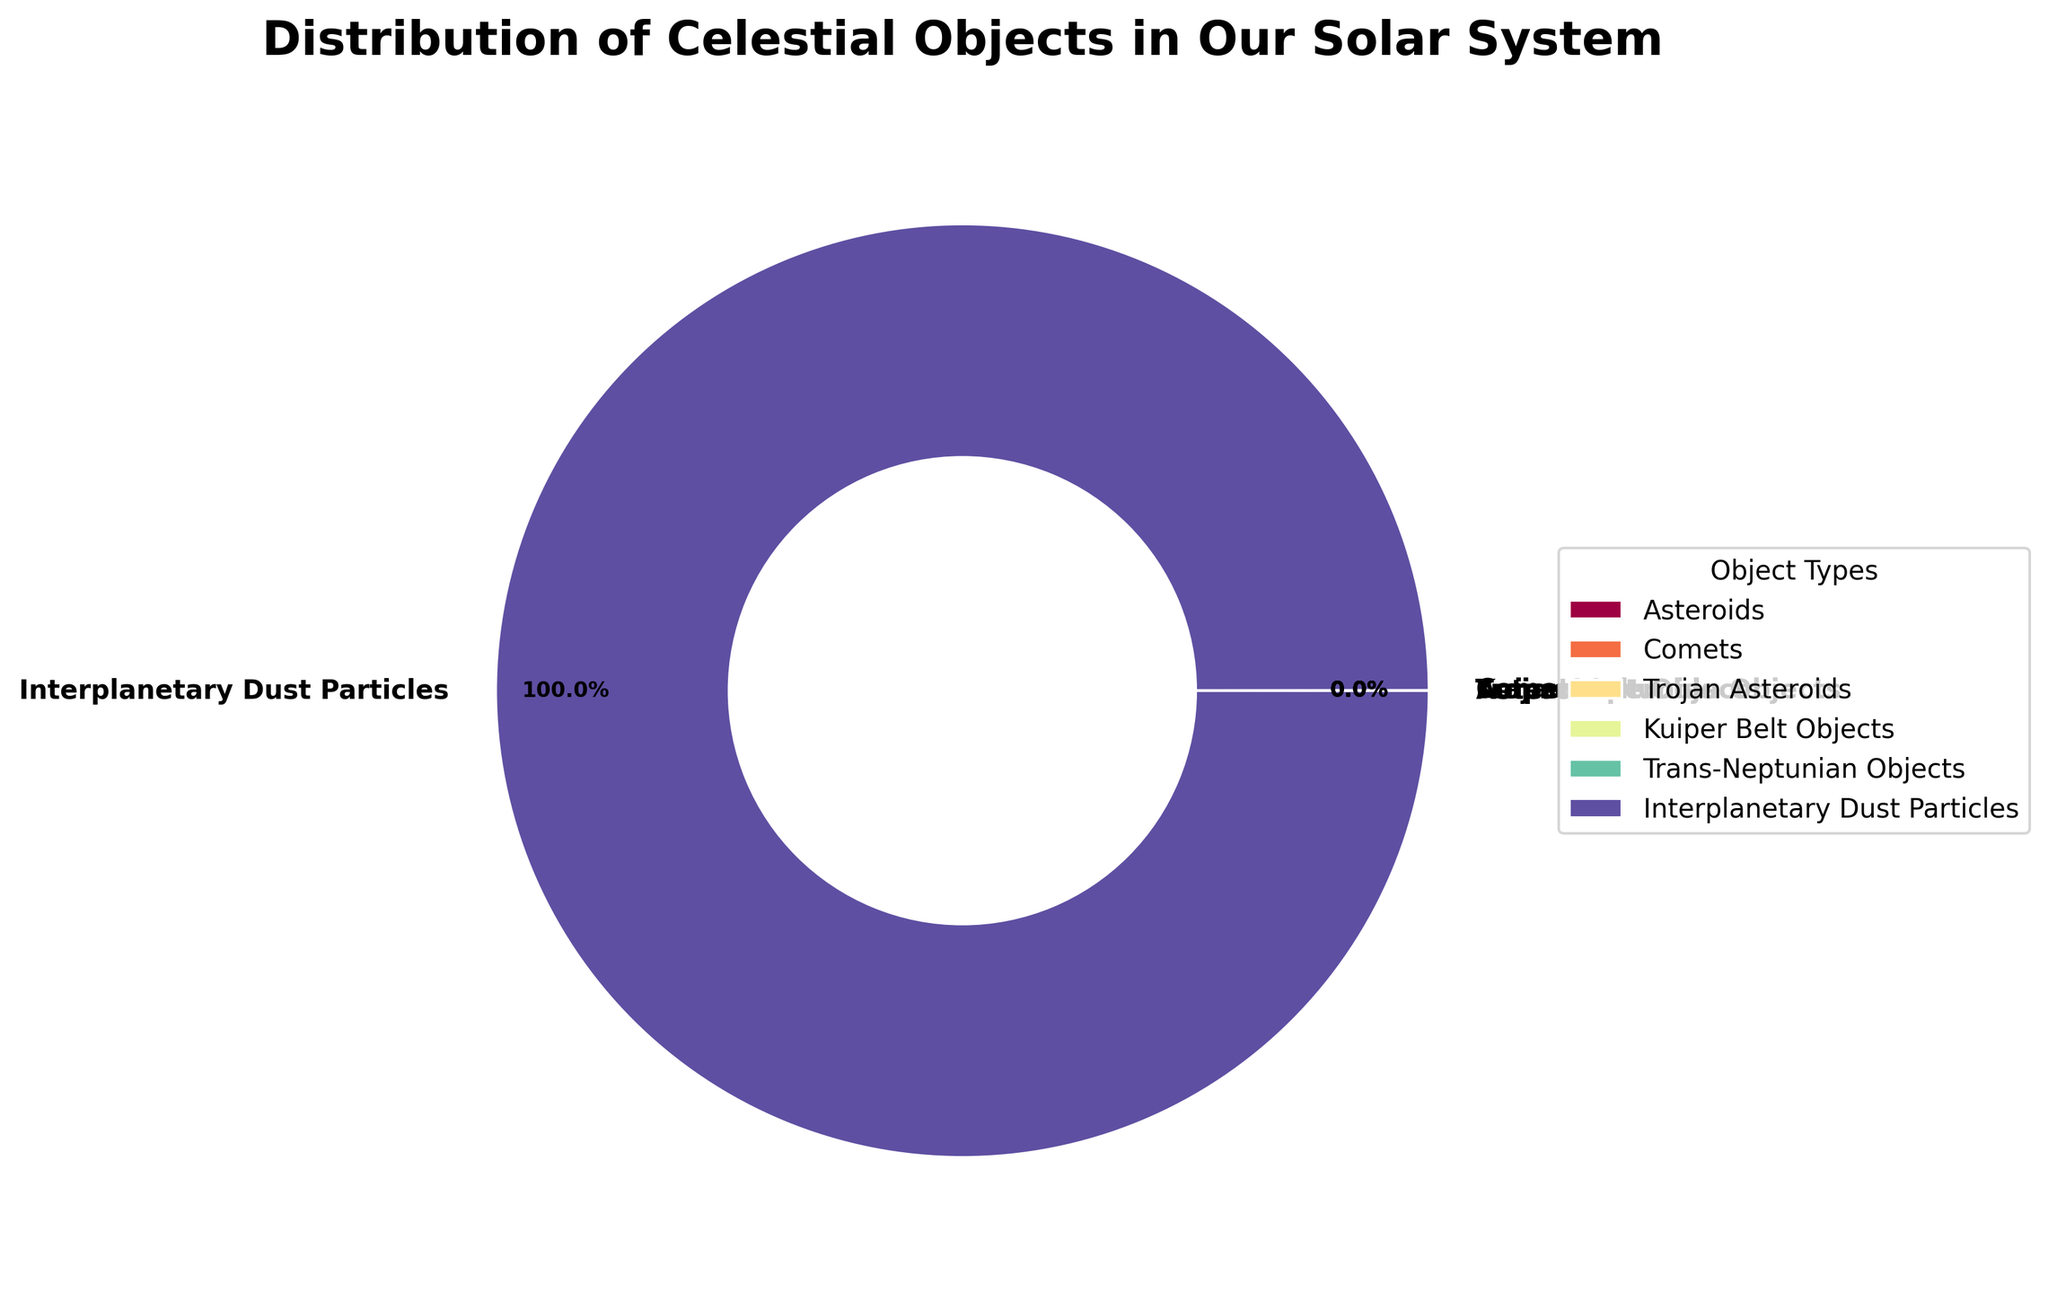Which type of celestial object comprises the largest portion of the pie chart? By visual inspection, the largest wedge in the pie chart represents "Interplanetary Dust Particles." The label and percentage displayed on the wedge confirm this.
Answer: Interplanetary Dust Particles Which celestial objects make up the smallest visible portion of the pie chart? By visual inspection, the smallest visible wedges in the pie chart are "Comets" and "Trans-Neptunian Objects."
Answer: Comets and Trans-Neptunian Objects How do the percentages of Asteroids and Kuiper Belt Objects compare? The pie chart wedges for "Asteroids" and "Kuiper Belt Objects" show their respective sizes. "Asteroids" have a much larger wedge, indicating they are a much higher percentage compared to "Kuiper Belt Objects."
Answer: Asteroids have a higher percentage than Kuiper Belt Objects What is the approximate percentage representation of Comets? By looking at the size of the "Comets" wedge and the percentage displayed on it in the pie chart, the approximate percentage can be found.
Answer: Approximately 0.4% Combine the percentages of Comets and Trans-Neptunian Objects. What is their total percentage? First, find the percentages of "Comets" and "Trans-Neptunian Objects" from the pie chart. Then, sum these percentages together.
Answer: Approximately 0.8% Which celestial object's percentage is closest to that of Trojan Asteroids? By comparing wedge sizes and percentages, the wedge for "Trans-Neptunian Objects" appears to be the closest in size to "Trojan Asteroids."
Answer: Trans-Neptunian Objects If you combine the planets and moons, what fraction of the total would they represent? Find the counts of "Planets" and "Moons" and add them together. Then find this combined count's percentage of total visual representation in the filtered dataset.
Answer: Approximately less than 1% 